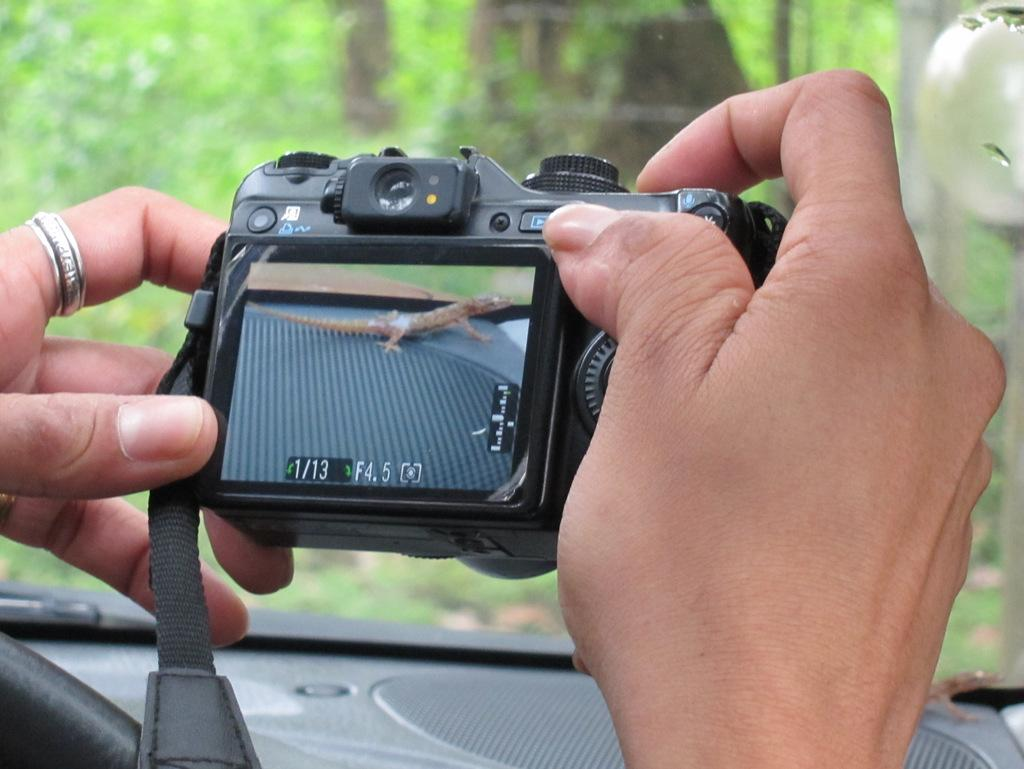<image>
Offer a succinct explanation of the picture presented. A person is looking at photo 1 of 13 on a digital camera. 